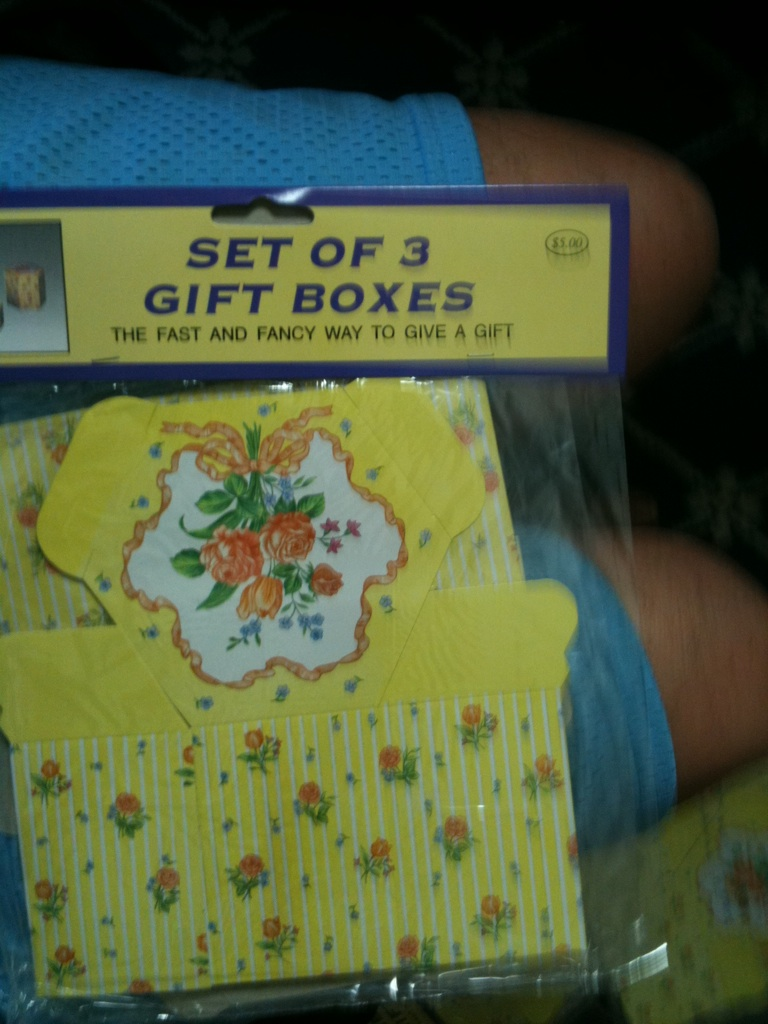What is this item? from Vizwiz set 3 gift boxes 